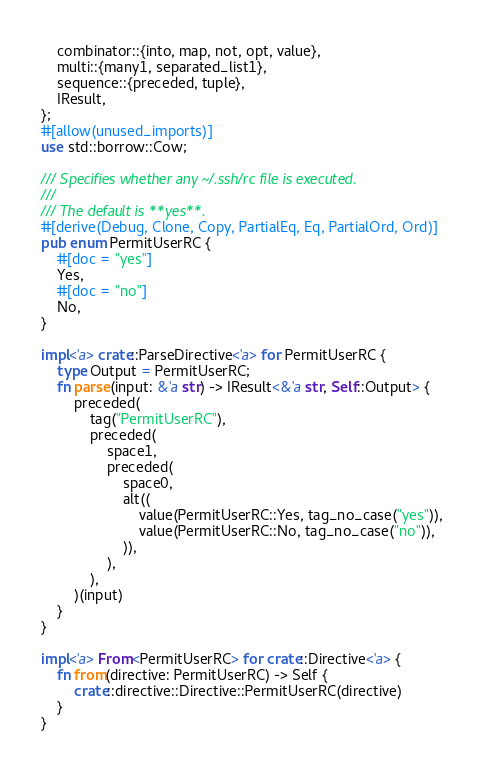Convert code to text. <code><loc_0><loc_0><loc_500><loc_500><_Rust_>    combinator::{into, map, not, opt, value},
    multi::{many1, separated_list1},
    sequence::{preceded, tuple},
    IResult,
};
#[allow(unused_imports)]
use std::borrow::Cow;

/// Specifies whether any ~/.ssh/rc file is executed.
///
/// The default is **yes**.
#[derive(Debug, Clone, Copy, PartialEq, Eq, PartialOrd, Ord)]
pub enum PermitUserRC {
    #[doc = "yes"]
    Yes,
    #[doc = "no"]
    No,
}

impl<'a> crate::ParseDirective<'a> for PermitUserRC {
    type Output = PermitUserRC;
    fn parse(input: &'a str) -> IResult<&'a str, Self::Output> {
        preceded(
            tag("PermitUserRC"),
            preceded(
                space1,
                preceded(
                    space0,
                    alt((
                        value(PermitUserRC::Yes, tag_no_case("yes")),
                        value(PermitUserRC::No, tag_no_case("no")),
                    )),
                ),
            ),
        )(input)
    }
}

impl<'a> From<PermitUserRC> for crate::Directive<'a> {
    fn from(directive: PermitUserRC) -> Self {
        crate::directive::Directive::PermitUserRC(directive)
    }
}
</code> 